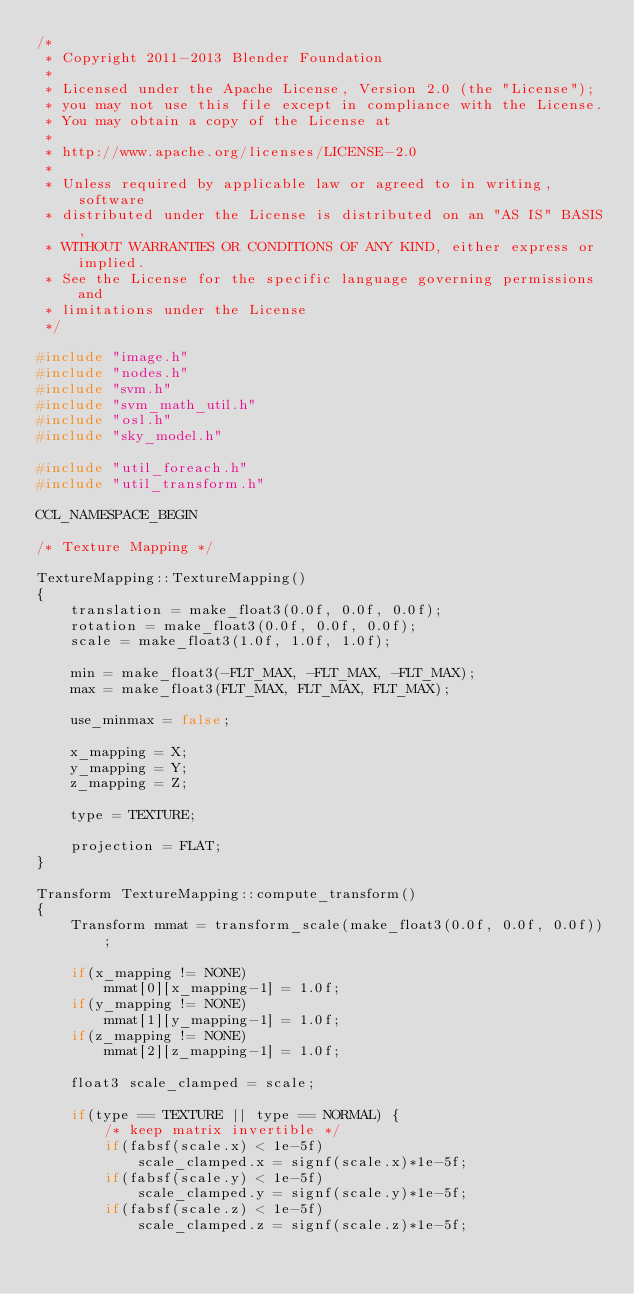<code> <loc_0><loc_0><loc_500><loc_500><_C++_>/*
 * Copyright 2011-2013 Blender Foundation
 *
 * Licensed under the Apache License, Version 2.0 (the "License");
 * you may not use this file except in compliance with the License.
 * You may obtain a copy of the License at
 *
 * http://www.apache.org/licenses/LICENSE-2.0
 *
 * Unless required by applicable law or agreed to in writing, software
 * distributed under the License is distributed on an "AS IS" BASIS,
 * WITHOUT WARRANTIES OR CONDITIONS OF ANY KIND, either express or implied.
 * See the License for the specific language governing permissions and
 * limitations under the License
 */

#include "image.h"
#include "nodes.h"
#include "svm.h"
#include "svm_math_util.h"
#include "osl.h"
#include "sky_model.h"

#include "util_foreach.h"
#include "util_transform.h"

CCL_NAMESPACE_BEGIN

/* Texture Mapping */

TextureMapping::TextureMapping()
{
	translation = make_float3(0.0f, 0.0f, 0.0f);
	rotation = make_float3(0.0f, 0.0f, 0.0f);
	scale = make_float3(1.0f, 1.0f, 1.0f);

	min = make_float3(-FLT_MAX, -FLT_MAX, -FLT_MAX);
	max = make_float3(FLT_MAX, FLT_MAX, FLT_MAX);

	use_minmax = false;

	x_mapping = X;
	y_mapping = Y;
	z_mapping = Z;

	type = TEXTURE;

	projection = FLAT;
}

Transform TextureMapping::compute_transform()
{
	Transform mmat = transform_scale(make_float3(0.0f, 0.0f, 0.0f));

	if(x_mapping != NONE)
		mmat[0][x_mapping-1] = 1.0f;
	if(y_mapping != NONE)
		mmat[1][y_mapping-1] = 1.0f;
	if(z_mapping != NONE)
		mmat[2][z_mapping-1] = 1.0f;
	
	float3 scale_clamped = scale;

	if(type == TEXTURE || type == NORMAL) {
		/* keep matrix invertible */
		if(fabsf(scale.x) < 1e-5f)
			scale_clamped.x = signf(scale.x)*1e-5f;
		if(fabsf(scale.y) < 1e-5f)
			scale_clamped.y = signf(scale.y)*1e-5f;
		if(fabsf(scale.z) < 1e-5f)
			scale_clamped.z = signf(scale.z)*1e-5f;</code> 